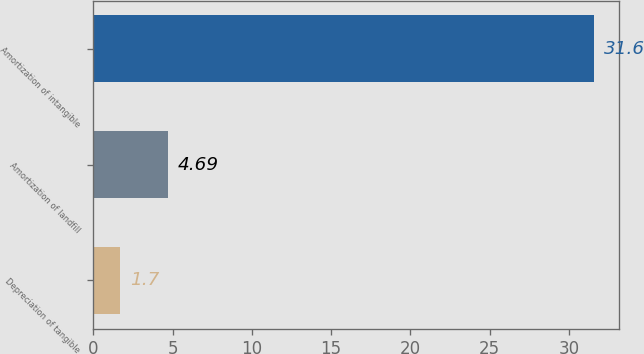Convert chart. <chart><loc_0><loc_0><loc_500><loc_500><bar_chart><fcel>Depreciation of tangible<fcel>Amortization of landfill<fcel>Amortization of intangible<nl><fcel>1.7<fcel>4.69<fcel>31.6<nl></chart> 